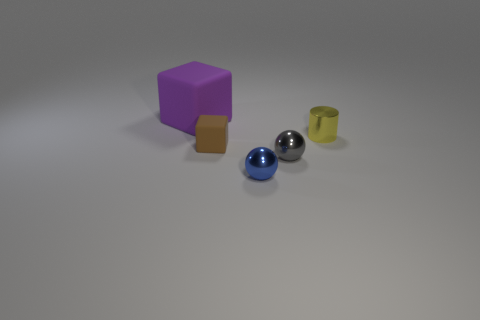Add 2 small gray things. How many objects exist? 7 Subtract all gray balls. How many purple cubes are left? 1 Add 1 large matte objects. How many large matte objects are left? 2 Add 5 tiny cyan cylinders. How many tiny cyan cylinders exist? 5 Subtract 0 purple cylinders. How many objects are left? 5 Subtract all cubes. How many objects are left? 3 Subtract 1 blocks. How many blocks are left? 1 Subtract all green blocks. Subtract all blue cylinders. How many blocks are left? 2 Subtract all metallic spheres. Subtract all rubber objects. How many objects are left? 1 